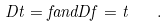<formula> <loc_0><loc_0><loc_500><loc_500>D t = f a n d D f = t \quad .</formula> 